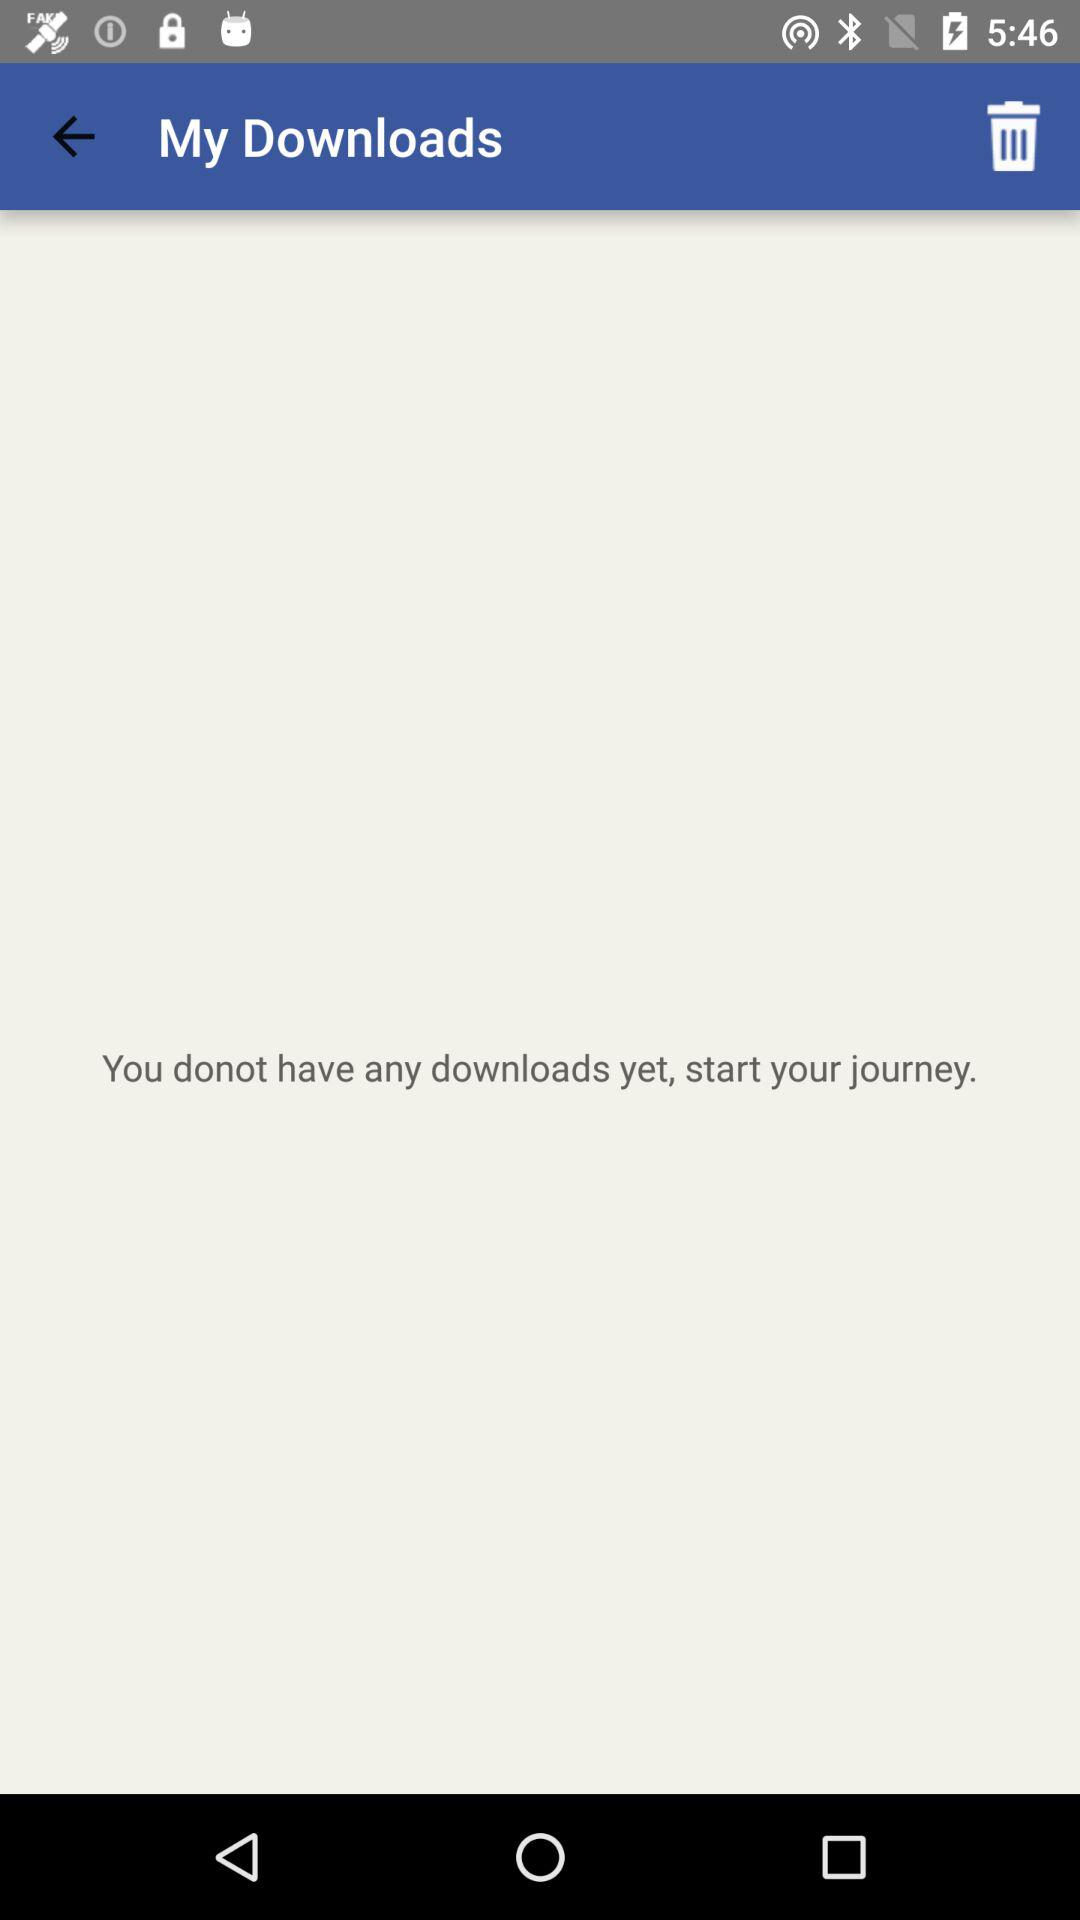How many downloads does the user have?
Answer the question using a single word or phrase. 0 